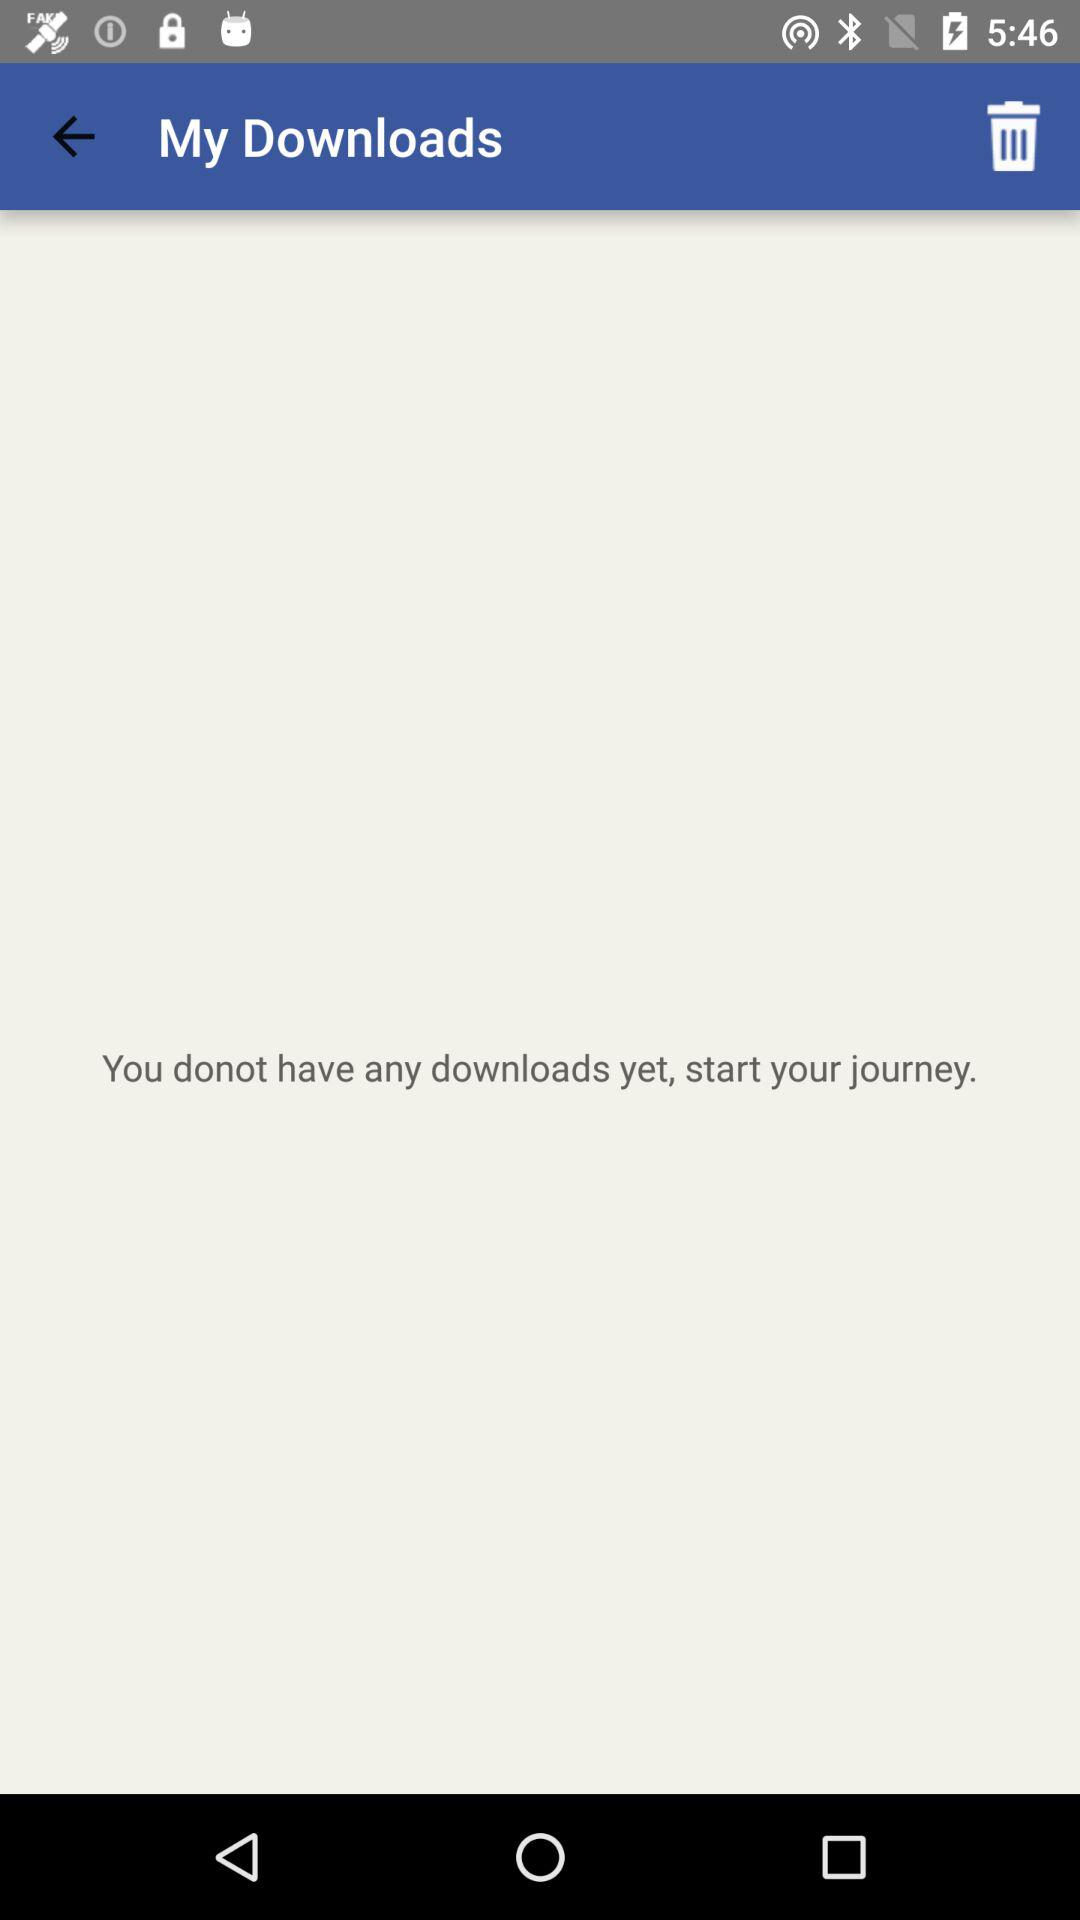How many downloads does the user have?
Answer the question using a single word or phrase. 0 